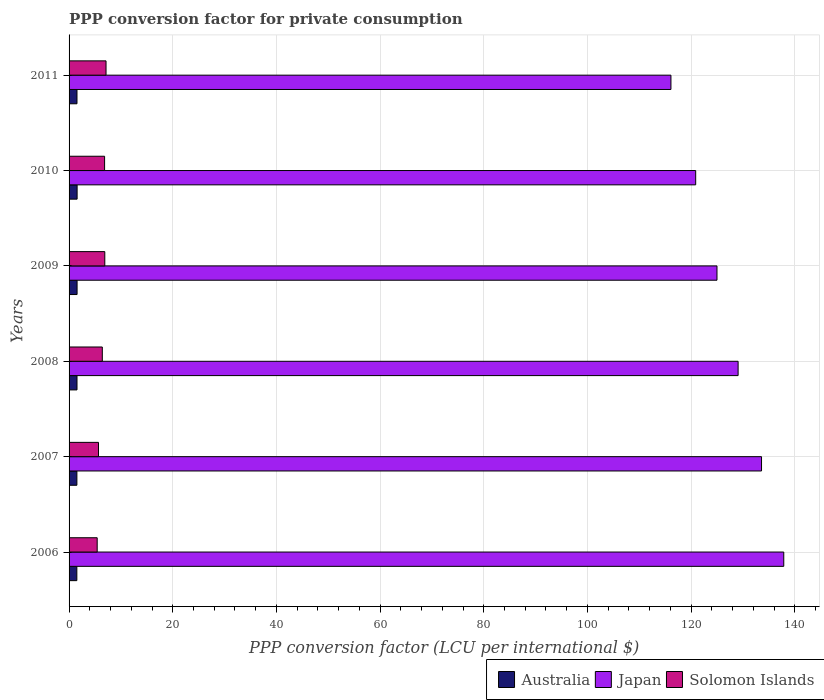How many different coloured bars are there?
Keep it short and to the point. 3. How many groups of bars are there?
Give a very brief answer. 6. How many bars are there on the 3rd tick from the top?
Your answer should be very brief. 3. How many bars are there on the 6th tick from the bottom?
Give a very brief answer. 3. What is the label of the 6th group of bars from the top?
Your answer should be compact. 2006. What is the PPP conversion factor for private consumption in Japan in 2007?
Offer a very short reply. 133.58. Across all years, what is the maximum PPP conversion factor for private consumption in Japan?
Your response must be concise. 137.87. Across all years, what is the minimum PPP conversion factor for private consumption in Solomon Islands?
Offer a very short reply. 5.42. In which year was the PPP conversion factor for private consumption in Australia maximum?
Your answer should be very brief. 2010. In which year was the PPP conversion factor for private consumption in Solomon Islands minimum?
Give a very brief answer. 2006. What is the total PPP conversion factor for private consumption in Japan in the graph?
Your answer should be very brief. 762.47. What is the difference between the PPP conversion factor for private consumption in Solomon Islands in 2007 and that in 2010?
Give a very brief answer. -1.18. What is the difference between the PPP conversion factor for private consumption in Australia in 2011 and the PPP conversion factor for private consumption in Japan in 2008?
Give a very brief answer. -127.53. What is the average PPP conversion factor for private consumption in Solomon Islands per year?
Offer a very short reply. 6.4. In the year 2008, what is the difference between the PPP conversion factor for private consumption in Japan and PPP conversion factor for private consumption in Solomon Islands?
Give a very brief answer. 122.65. What is the ratio of the PPP conversion factor for private consumption in Australia in 2007 to that in 2010?
Provide a succinct answer. 0.97. Is the difference between the PPP conversion factor for private consumption in Japan in 2006 and 2009 greater than the difference between the PPP conversion factor for private consumption in Solomon Islands in 2006 and 2009?
Ensure brevity in your answer.  Yes. What is the difference between the highest and the second highest PPP conversion factor for private consumption in Solomon Islands?
Your answer should be very brief. 0.24. What is the difference between the highest and the lowest PPP conversion factor for private consumption in Japan?
Keep it short and to the point. 21.76. Is the sum of the PPP conversion factor for private consumption in Solomon Islands in 2006 and 2009 greater than the maximum PPP conversion factor for private consumption in Japan across all years?
Provide a succinct answer. No. What does the 1st bar from the top in 2010 represents?
Ensure brevity in your answer.  Solomon Islands. Is it the case that in every year, the sum of the PPP conversion factor for private consumption in Solomon Islands and PPP conversion factor for private consumption in Japan is greater than the PPP conversion factor for private consumption in Australia?
Provide a succinct answer. Yes. How many bars are there?
Provide a succinct answer. 18. What is the difference between two consecutive major ticks on the X-axis?
Your answer should be compact. 20. Does the graph contain grids?
Your answer should be very brief. Yes. Where does the legend appear in the graph?
Offer a terse response. Bottom right. How many legend labels are there?
Offer a very short reply. 3. What is the title of the graph?
Provide a short and direct response. PPP conversion factor for private consumption. Does "Mexico" appear as one of the legend labels in the graph?
Provide a short and direct response. No. What is the label or title of the X-axis?
Offer a terse response. PPP conversion factor (LCU per international $). What is the label or title of the Y-axis?
Make the answer very short. Years. What is the PPP conversion factor (LCU per international $) of Australia in 2006?
Your answer should be very brief. 1.5. What is the PPP conversion factor (LCU per international $) in Japan in 2006?
Your answer should be compact. 137.87. What is the PPP conversion factor (LCU per international $) of Solomon Islands in 2006?
Provide a succinct answer. 5.42. What is the PPP conversion factor (LCU per international $) in Australia in 2007?
Keep it short and to the point. 1.51. What is the PPP conversion factor (LCU per international $) in Japan in 2007?
Offer a very short reply. 133.58. What is the PPP conversion factor (LCU per international $) in Solomon Islands in 2007?
Your response must be concise. 5.68. What is the PPP conversion factor (LCU per international $) of Australia in 2008?
Provide a short and direct response. 1.53. What is the PPP conversion factor (LCU per international $) in Japan in 2008?
Offer a terse response. 129.06. What is the PPP conversion factor (LCU per international $) in Solomon Islands in 2008?
Keep it short and to the point. 6.41. What is the PPP conversion factor (LCU per international $) in Australia in 2009?
Make the answer very short. 1.54. What is the PPP conversion factor (LCU per international $) in Japan in 2009?
Your response must be concise. 124.99. What is the PPP conversion factor (LCU per international $) in Solomon Islands in 2009?
Your answer should be compact. 6.89. What is the PPP conversion factor (LCU per international $) of Australia in 2010?
Offer a very short reply. 1.55. What is the PPP conversion factor (LCU per international $) of Japan in 2010?
Keep it short and to the point. 120.88. What is the PPP conversion factor (LCU per international $) in Solomon Islands in 2010?
Keep it short and to the point. 6.85. What is the PPP conversion factor (LCU per international $) in Australia in 2011?
Ensure brevity in your answer.  1.53. What is the PPP conversion factor (LCU per international $) of Japan in 2011?
Your answer should be compact. 116.1. What is the PPP conversion factor (LCU per international $) in Solomon Islands in 2011?
Your answer should be very brief. 7.13. Across all years, what is the maximum PPP conversion factor (LCU per international $) of Australia?
Your answer should be very brief. 1.55. Across all years, what is the maximum PPP conversion factor (LCU per international $) in Japan?
Your answer should be compact. 137.87. Across all years, what is the maximum PPP conversion factor (LCU per international $) of Solomon Islands?
Provide a short and direct response. 7.13. Across all years, what is the minimum PPP conversion factor (LCU per international $) of Australia?
Provide a succinct answer. 1.5. Across all years, what is the minimum PPP conversion factor (LCU per international $) in Japan?
Your answer should be compact. 116.1. Across all years, what is the minimum PPP conversion factor (LCU per international $) in Solomon Islands?
Offer a very short reply. 5.42. What is the total PPP conversion factor (LCU per international $) in Australia in the graph?
Offer a very short reply. 9.16. What is the total PPP conversion factor (LCU per international $) in Japan in the graph?
Ensure brevity in your answer.  762.47. What is the total PPP conversion factor (LCU per international $) of Solomon Islands in the graph?
Give a very brief answer. 38.39. What is the difference between the PPP conversion factor (LCU per international $) in Australia in 2006 and that in 2007?
Your answer should be very brief. -0.01. What is the difference between the PPP conversion factor (LCU per international $) of Japan in 2006 and that in 2007?
Your response must be concise. 4.29. What is the difference between the PPP conversion factor (LCU per international $) of Solomon Islands in 2006 and that in 2007?
Your response must be concise. -0.25. What is the difference between the PPP conversion factor (LCU per international $) in Australia in 2006 and that in 2008?
Give a very brief answer. -0.03. What is the difference between the PPP conversion factor (LCU per international $) in Japan in 2006 and that in 2008?
Keep it short and to the point. 8.81. What is the difference between the PPP conversion factor (LCU per international $) in Solomon Islands in 2006 and that in 2008?
Provide a succinct answer. -0.99. What is the difference between the PPP conversion factor (LCU per international $) in Australia in 2006 and that in 2009?
Offer a very short reply. -0.05. What is the difference between the PPP conversion factor (LCU per international $) of Japan in 2006 and that in 2009?
Offer a terse response. 12.88. What is the difference between the PPP conversion factor (LCU per international $) of Solomon Islands in 2006 and that in 2009?
Make the answer very short. -1.47. What is the difference between the PPP conversion factor (LCU per international $) of Australia in 2006 and that in 2010?
Keep it short and to the point. -0.05. What is the difference between the PPP conversion factor (LCU per international $) in Japan in 2006 and that in 2010?
Make the answer very short. 16.99. What is the difference between the PPP conversion factor (LCU per international $) of Solomon Islands in 2006 and that in 2010?
Keep it short and to the point. -1.43. What is the difference between the PPP conversion factor (LCU per international $) in Australia in 2006 and that in 2011?
Ensure brevity in your answer.  -0.03. What is the difference between the PPP conversion factor (LCU per international $) in Japan in 2006 and that in 2011?
Your answer should be very brief. 21.76. What is the difference between the PPP conversion factor (LCU per international $) in Solomon Islands in 2006 and that in 2011?
Keep it short and to the point. -1.71. What is the difference between the PPP conversion factor (LCU per international $) of Australia in 2007 and that in 2008?
Provide a short and direct response. -0.02. What is the difference between the PPP conversion factor (LCU per international $) in Japan in 2007 and that in 2008?
Give a very brief answer. 4.52. What is the difference between the PPP conversion factor (LCU per international $) of Solomon Islands in 2007 and that in 2008?
Your answer should be compact. -0.74. What is the difference between the PPP conversion factor (LCU per international $) in Australia in 2007 and that in 2009?
Give a very brief answer. -0.04. What is the difference between the PPP conversion factor (LCU per international $) of Japan in 2007 and that in 2009?
Provide a succinct answer. 8.59. What is the difference between the PPP conversion factor (LCU per international $) of Solomon Islands in 2007 and that in 2009?
Your answer should be compact. -1.22. What is the difference between the PPP conversion factor (LCU per international $) of Australia in 2007 and that in 2010?
Your answer should be very brief. -0.04. What is the difference between the PPP conversion factor (LCU per international $) of Japan in 2007 and that in 2010?
Ensure brevity in your answer.  12.7. What is the difference between the PPP conversion factor (LCU per international $) in Solomon Islands in 2007 and that in 2010?
Keep it short and to the point. -1.18. What is the difference between the PPP conversion factor (LCU per international $) in Australia in 2007 and that in 2011?
Your answer should be very brief. -0.02. What is the difference between the PPP conversion factor (LCU per international $) of Japan in 2007 and that in 2011?
Keep it short and to the point. 17.48. What is the difference between the PPP conversion factor (LCU per international $) in Solomon Islands in 2007 and that in 2011?
Your answer should be compact. -1.45. What is the difference between the PPP conversion factor (LCU per international $) in Australia in 2008 and that in 2009?
Make the answer very short. -0.01. What is the difference between the PPP conversion factor (LCU per international $) in Japan in 2008 and that in 2009?
Your answer should be compact. 4.07. What is the difference between the PPP conversion factor (LCU per international $) in Solomon Islands in 2008 and that in 2009?
Provide a succinct answer. -0.48. What is the difference between the PPP conversion factor (LCU per international $) of Australia in 2008 and that in 2010?
Ensure brevity in your answer.  -0.02. What is the difference between the PPP conversion factor (LCU per international $) in Japan in 2008 and that in 2010?
Your answer should be compact. 8.18. What is the difference between the PPP conversion factor (LCU per international $) in Solomon Islands in 2008 and that in 2010?
Your answer should be very brief. -0.44. What is the difference between the PPP conversion factor (LCU per international $) of Australia in 2008 and that in 2011?
Your answer should be very brief. 0. What is the difference between the PPP conversion factor (LCU per international $) of Japan in 2008 and that in 2011?
Provide a short and direct response. 12.96. What is the difference between the PPP conversion factor (LCU per international $) in Solomon Islands in 2008 and that in 2011?
Provide a short and direct response. -0.72. What is the difference between the PPP conversion factor (LCU per international $) of Australia in 2009 and that in 2010?
Your response must be concise. -0.01. What is the difference between the PPP conversion factor (LCU per international $) of Japan in 2009 and that in 2010?
Give a very brief answer. 4.11. What is the difference between the PPP conversion factor (LCU per international $) in Solomon Islands in 2009 and that in 2010?
Make the answer very short. 0.04. What is the difference between the PPP conversion factor (LCU per international $) in Australia in 2009 and that in 2011?
Ensure brevity in your answer.  0.02. What is the difference between the PPP conversion factor (LCU per international $) of Japan in 2009 and that in 2011?
Your answer should be very brief. 8.88. What is the difference between the PPP conversion factor (LCU per international $) in Solomon Islands in 2009 and that in 2011?
Your answer should be compact. -0.24. What is the difference between the PPP conversion factor (LCU per international $) of Australia in 2010 and that in 2011?
Offer a terse response. 0.03. What is the difference between the PPP conversion factor (LCU per international $) of Japan in 2010 and that in 2011?
Ensure brevity in your answer.  4.78. What is the difference between the PPP conversion factor (LCU per international $) of Solomon Islands in 2010 and that in 2011?
Keep it short and to the point. -0.28. What is the difference between the PPP conversion factor (LCU per international $) in Australia in 2006 and the PPP conversion factor (LCU per international $) in Japan in 2007?
Provide a short and direct response. -132.08. What is the difference between the PPP conversion factor (LCU per international $) of Australia in 2006 and the PPP conversion factor (LCU per international $) of Solomon Islands in 2007?
Make the answer very short. -4.18. What is the difference between the PPP conversion factor (LCU per international $) in Japan in 2006 and the PPP conversion factor (LCU per international $) in Solomon Islands in 2007?
Keep it short and to the point. 132.19. What is the difference between the PPP conversion factor (LCU per international $) of Australia in 2006 and the PPP conversion factor (LCU per international $) of Japan in 2008?
Provide a succinct answer. -127.56. What is the difference between the PPP conversion factor (LCU per international $) of Australia in 2006 and the PPP conversion factor (LCU per international $) of Solomon Islands in 2008?
Your response must be concise. -4.92. What is the difference between the PPP conversion factor (LCU per international $) of Japan in 2006 and the PPP conversion factor (LCU per international $) of Solomon Islands in 2008?
Your response must be concise. 131.45. What is the difference between the PPP conversion factor (LCU per international $) of Australia in 2006 and the PPP conversion factor (LCU per international $) of Japan in 2009?
Your response must be concise. -123.49. What is the difference between the PPP conversion factor (LCU per international $) of Australia in 2006 and the PPP conversion factor (LCU per international $) of Solomon Islands in 2009?
Offer a very short reply. -5.39. What is the difference between the PPP conversion factor (LCU per international $) of Japan in 2006 and the PPP conversion factor (LCU per international $) of Solomon Islands in 2009?
Offer a terse response. 130.97. What is the difference between the PPP conversion factor (LCU per international $) of Australia in 2006 and the PPP conversion factor (LCU per international $) of Japan in 2010?
Your answer should be very brief. -119.38. What is the difference between the PPP conversion factor (LCU per international $) of Australia in 2006 and the PPP conversion factor (LCU per international $) of Solomon Islands in 2010?
Your answer should be compact. -5.36. What is the difference between the PPP conversion factor (LCU per international $) of Japan in 2006 and the PPP conversion factor (LCU per international $) of Solomon Islands in 2010?
Your answer should be compact. 131.01. What is the difference between the PPP conversion factor (LCU per international $) in Australia in 2006 and the PPP conversion factor (LCU per international $) in Japan in 2011?
Your answer should be compact. -114.61. What is the difference between the PPP conversion factor (LCU per international $) in Australia in 2006 and the PPP conversion factor (LCU per international $) in Solomon Islands in 2011?
Keep it short and to the point. -5.63. What is the difference between the PPP conversion factor (LCU per international $) of Japan in 2006 and the PPP conversion factor (LCU per international $) of Solomon Islands in 2011?
Provide a short and direct response. 130.74. What is the difference between the PPP conversion factor (LCU per international $) of Australia in 2007 and the PPP conversion factor (LCU per international $) of Japan in 2008?
Your answer should be very brief. -127.55. What is the difference between the PPP conversion factor (LCU per international $) of Australia in 2007 and the PPP conversion factor (LCU per international $) of Solomon Islands in 2008?
Provide a succinct answer. -4.91. What is the difference between the PPP conversion factor (LCU per international $) of Japan in 2007 and the PPP conversion factor (LCU per international $) of Solomon Islands in 2008?
Offer a very short reply. 127.17. What is the difference between the PPP conversion factor (LCU per international $) in Australia in 2007 and the PPP conversion factor (LCU per international $) in Japan in 2009?
Offer a terse response. -123.48. What is the difference between the PPP conversion factor (LCU per international $) in Australia in 2007 and the PPP conversion factor (LCU per international $) in Solomon Islands in 2009?
Provide a succinct answer. -5.39. What is the difference between the PPP conversion factor (LCU per international $) in Japan in 2007 and the PPP conversion factor (LCU per international $) in Solomon Islands in 2009?
Make the answer very short. 126.69. What is the difference between the PPP conversion factor (LCU per international $) in Australia in 2007 and the PPP conversion factor (LCU per international $) in Japan in 2010?
Make the answer very short. -119.37. What is the difference between the PPP conversion factor (LCU per international $) in Australia in 2007 and the PPP conversion factor (LCU per international $) in Solomon Islands in 2010?
Offer a terse response. -5.35. What is the difference between the PPP conversion factor (LCU per international $) in Japan in 2007 and the PPP conversion factor (LCU per international $) in Solomon Islands in 2010?
Provide a short and direct response. 126.73. What is the difference between the PPP conversion factor (LCU per international $) in Australia in 2007 and the PPP conversion factor (LCU per international $) in Japan in 2011?
Provide a short and direct response. -114.6. What is the difference between the PPP conversion factor (LCU per international $) in Australia in 2007 and the PPP conversion factor (LCU per international $) in Solomon Islands in 2011?
Provide a succinct answer. -5.62. What is the difference between the PPP conversion factor (LCU per international $) in Japan in 2007 and the PPP conversion factor (LCU per international $) in Solomon Islands in 2011?
Keep it short and to the point. 126.45. What is the difference between the PPP conversion factor (LCU per international $) in Australia in 2008 and the PPP conversion factor (LCU per international $) in Japan in 2009?
Your response must be concise. -123.46. What is the difference between the PPP conversion factor (LCU per international $) of Australia in 2008 and the PPP conversion factor (LCU per international $) of Solomon Islands in 2009?
Provide a succinct answer. -5.36. What is the difference between the PPP conversion factor (LCU per international $) in Japan in 2008 and the PPP conversion factor (LCU per international $) in Solomon Islands in 2009?
Provide a succinct answer. 122.17. What is the difference between the PPP conversion factor (LCU per international $) in Australia in 2008 and the PPP conversion factor (LCU per international $) in Japan in 2010?
Make the answer very short. -119.35. What is the difference between the PPP conversion factor (LCU per international $) in Australia in 2008 and the PPP conversion factor (LCU per international $) in Solomon Islands in 2010?
Make the answer very short. -5.32. What is the difference between the PPP conversion factor (LCU per international $) in Japan in 2008 and the PPP conversion factor (LCU per international $) in Solomon Islands in 2010?
Ensure brevity in your answer.  122.21. What is the difference between the PPP conversion factor (LCU per international $) in Australia in 2008 and the PPP conversion factor (LCU per international $) in Japan in 2011?
Your response must be concise. -114.57. What is the difference between the PPP conversion factor (LCU per international $) of Australia in 2008 and the PPP conversion factor (LCU per international $) of Solomon Islands in 2011?
Ensure brevity in your answer.  -5.6. What is the difference between the PPP conversion factor (LCU per international $) of Japan in 2008 and the PPP conversion factor (LCU per international $) of Solomon Islands in 2011?
Provide a short and direct response. 121.93. What is the difference between the PPP conversion factor (LCU per international $) in Australia in 2009 and the PPP conversion factor (LCU per international $) in Japan in 2010?
Your answer should be very brief. -119.33. What is the difference between the PPP conversion factor (LCU per international $) of Australia in 2009 and the PPP conversion factor (LCU per international $) of Solomon Islands in 2010?
Provide a short and direct response. -5.31. What is the difference between the PPP conversion factor (LCU per international $) of Japan in 2009 and the PPP conversion factor (LCU per international $) of Solomon Islands in 2010?
Your answer should be very brief. 118.13. What is the difference between the PPP conversion factor (LCU per international $) of Australia in 2009 and the PPP conversion factor (LCU per international $) of Japan in 2011?
Provide a succinct answer. -114.56. What is the difference between the PPP conversion factor (LCU per international $) in Australia in 2009 and the PPP conversion factor (LCU per international $) in Solomon Islands in 2011?
Make the answer very short. -5.59. What is the difference between the PPP conversion factor (LCU per international $) of Japan in 2009 and the PPP conversion factor (LCU per international $) of Solomon Islands in 2011?
Give a very brief answer. 117.85. What is the difference between the PPP conversion factor (LCU per international $) of Australia in 2010 and the PPP conversion factor (LCU per international $) of Japan in 2011?
Your answer should be compact. -114.55. What is the difference between the PPP conversion factor (LCU per international $) in Australia in 2010 and the PPP conversion factor (LCU per international $) in Solomon Islands in 2011?
Keep it short and to the point. -5.58. What is the difference between the PPP conversion factor (LCU per international $) in Japan in 2010 and the PPP conversion factor (LCU per international $) in Solomon Islands in 2011?
Give a very brief answer. 113.75. What is the average PPP conversion factor (LCU per international $) in Australia per year?
Ensure brevity in your answer.  1.53. What is the average PPP conversion factor (LCU per international $) in Japan per year?
Offer a terse response. 127.08. What is the average PPP conversion factor (LCU per international $) of Solomon Islands per year?
Your answer should be compact. 6.4. In the year 2006, what is the difference between the PPP conversion factor (LCU per international $) of Australia and PPP conversion factor (LCU per international $) of Japan?
Your answer should be compact. -136.37. In the year 2006, what is the difference between the PPP conversion factor (LCU per international $) of Australia and PPP conversion factor (LCU per international $) of Solomon Islands?
Your answer should be very brief. -3.92. In the year 2006, what is the difference between the PPP conversion factor (LCU per international $) of Japan and PPP conversion factor (LCU per international $) of Solomon Islands?
Make the answer very short. 132.44. In the year 2007, what is the difference between the PPP conversion factor (LCU per international $) of Australia and PPP conversion factor (LCU per international $) of Japan?
Your answer should be compact. -132.07. In the year 2007, what is the difference between the PPP conversion factor (LCU per international $) in Australia and PPP conversion factor (LCU per international $) in Solomon Islands?
Offer a terse response. -4.17. In the year 2007, what is the difference between the PPP conversion factor (LCU per international $) of Japan and PPP conversion factor (LCU per international $) of Solomon Islands?
Make the answer very short. 127.9. In the year 2008, what is the difference between the PPP conversion factor (LCU per international $) in Australia and PPP conversion factor (LCU per international $) in Japan?
Keep it short and to the point. -127.53. In the year 2008, what is the difference between the PPP conversion factor (LCU per international $) in Australia and PPP conversion factor (LCU per international $) in Solomon Islands?
Provide a short and direct response. -4.88. In the year 2008, what is the difference between the PPP conversion factor (LCU per international $) in Japan and PPP conversion factor (LCU per international $) in Solomon Islands?
Give a very brief answer. 122.65. In the year 2009, what is the difference between the PPP conversion factor (LCU per international $) of Australia and PPP conversion factor (LCU per international $) of Japan?
Offer a very short reply. -123.44. In the year 2009, what is the difference between the PPP conversion factor (LCU per international $) in Australia and PPP conversion factor (LCU per international $) in Solomon Islands?
Offer a terse response. -5.35. In the year 2009, what is the difference between the PPP conversion factor (LCU per international $) of Japan and PPP conversion factor (LCU per international $) of Solomon Islands?
Keep it short and to the point. 118.09. In the year 2010, what is the difference between the PPP conversion factor (LCU per international $) of Australia and PPP conversion factor (LCU per international $) of Japan?
Your response must be concise. -119.33. In the year 2010, what is the difference between the PPP conversion factor (LCU per international $) in Australia and PPP conversion factor (LCU per international $) in Solomon Islands?
Your response must be concise. -5.3. In the year 2010, what is the difference between the PPP conversion factor (LCU per international $) of Japan and PPP conversion factor (LCU per international $) of Solomon Islands?
Provide a succinct answer. 114.03. In the year 2011, what is the difference between the PPP conversion factor (LCU per international $) of Australia and PPP conversion factor (LCU per international $) of Japan?
Your answer should be compact. -114.58. In the year 2011, what is the difference between the PPP conversion factor (LCU per international $) of Australia and PPP conversion factor (LCU per international $) of Solomon Islands?
Your answer should be compact. -5.6. In the year 2011, what is the difference between the PPP conversion factor (LCU per international $) in Japan and PPP conversion factor (LCU per international $) in Solomon Islands?
Offer a terse response. 108.97. What is the ratio of the PPP conversion factor (LCU per international $) in Australia in 2006 to that in 2007?
Offer a terse response. 0.99. What is the ratio of the PPP conversion factor (LCU per international $) in Japan in 2006 to that in 2007?
Offer a very short reply. 1.03. What is the ratio of the PPP conversion factor (LCU per international $) of Solomon Islands in 2006 to that in 2007?
Keep it short and to the point. 0.96. What is the ratio of the PPP conversion factor (LCU per international $) in Australia in 2006 to that in 2008?
Your answer should be compact. 0.98. What is the ratio of the PPP conversion factor (LCU per international $) of Japan in 2006 to that in 2008?
Offer a very short reply. 1.07. What is the ratio of the PPP conversion factor (LCU per international $) of Solomon Islands in 2006 to that in 2008?
Your answer should be compact. 0.85. What is the ratio of the PPP conversion factor (LCU per international $) in Australia in 2006 to that in 2009?
Give a very brief answer. 0.97. What is the ratio of the PPP conversion factor (LCU per international $) of Japan in 2006 to that in 2009?
Provide a short and direct response. 1.1. What is the ratio of the PPP conversion factor (LCU per international $) in Solomon Islands in 2006 to that in 2009?
Provide a succinct answer. 0.79. What is the ratio of the PPP conversion factor (LCU per international $) in Australia in 2006 to that in 2010?
Make the answer very short. 0.97. What is the ratio of the PPP conversion factor (LCU per international $) of Japan in 2006 to that in 2010?
Your answer should be compact. 1.14. What is the ratio of the PPP conversion factor (LCU per international $) in Solomon Islands in 2006 to that in 2010?
Give a very brief answer. 0.79. What is the ratio of the PPP conversion factor (LCU per international $) of Australia in 2006 to that in 2011?
Make the answer very short. 0.98. What is the ratio of the PPP conversion factor (LCU per international $) of Japan in 2006 to that in 2011?
Ensure brevity in your answer.  1.19. What is the ratio of the PPP conversion factor (LCU per international $) in Solomon Islands in 2006 to that in 2011?
Your response must be concise. 0.76. What is the ratio of the PPP conversion factor (LCU per international $) in Australia in 2007 to that in 2008?
Provide a succinct answer. 0.98. What is the ratio of the PPP conversion factor (LCU per international $) in Japan in 2007 to that in 2008?
Provide a succinct answer. 1.03. What is the ratio of the PPP conversion factor (LCU per international $) of Solomon Islands in 2007 to that in 2008?
Keep it short and to the point. 0.89. What is the ratio of the PPP conversion factor (LCU per international $) in Australia in 2007 to that in 2009?
Offer a very short reply. 0.98. What is the ratio of the PPP conversion factor (LCU per international $) in Japan in 2007 to that in 2009?
Keep it short and to the point. 1.07. What is the ratio of the PPP conversion factor (LCU per international $) of Solomon Islands in 2007 to that in 2009?
Offer a very short reply. 0.82. What is the ratio of the PPP conversion factor (LCU per international $) in Australia in 2007 to that in 2010?
Keep it short and to the point. 0.97. What is the ratio of the PPP conversion factor (LCU per international $) in Japan in 2007 to that in 2010?
Your answer should be very brief. 1.11. What is the ratio of the PPP conversion factor (LCU per international $) in Solomon Islands in 2007 to that in 2010?
Your answer should be very brief. 0.83. What is the ratio of the PPP conversion factor (LCU per international $) of Australia in 2007 to that in 2011?
Provide a short and direct response. 0.99. What is the ratio of the PPP conversion factor (LCU per international $) of Japan in 2007 to that in 2011?
Offer a terse response. 1.15. What is the ratio of the PPP conversion factor (LCU per international $) of Solomon Islands in 2007 to that in 2011?
Your answer should be compact. 0.8. What is the ratio of the PPP conversion factor (LCU per international $) of Australia in 2008 to that in 2009?
Ensure brevity in your answer.  0.99. What is the ratio of the PPP conversion factor (LCU per international $) in Japan in 2008 to that in 2009?
Your answer should be very brief. 1.03. What is the ratio of the PPP conversion factor (LCU per international $) of Solomon Islands in 2008 to that in 2009?
Make the answer very short. 0.93. What is the ratio of the PPP conversion factor (LCU per international $) of Australia in 2008 to that in 2010?
Your answer should be very brief. 0.99. What is the ratio of the PPP conversion factor (LCU per international $) in Japan in 2008 to that in 2010?
Provide a short and direct response. 1.07. What is the ratio of the PPP conversion factor (LCU per international $) in Solomon Islands in 2008 to that in 2010?
Make the answer very short. 0.94. What is the ratio of the PPP conversion factor (LCU per international $) in Japan in 2008 to that in 2011?
Offer a terse response. 1.11. What is the ratio of the PPP conversion factor (LCU per international $) in Solomon Islands in 2008 to that in 2011?
Provide a short and direct response. 0.9. What is the ratio of the PPP conversion factor (LCU per international $) of Australia in 2009 to that in 2010?
Provide a short and direct response. 0.99. What is the ratio of the PPP conversion factor (LCU per international $) in Japan in 2009 to that in 2010?
Keep it short and to the point. 1.03. What is the ratio of the PPP conversion factor (LCU per international $) in Solomon Islands in 2009 to that in 2010?
Your answer should be very brief. 1.01. What is the ratio of the PPP conversion factor (LCU per international $) of Australia in 2009 to that in 2011?
Keep it short and to the point. 1.01. What is the ratio of the PPP conversion factor (LCU per international $) of Japan in 2009 to that in 2011?
Your answer should be compact. 1.08. What is the ratio of the PPP conversion factor (LCU per international $) of Solomon Islands in 2009 to that in 2011?
Offer a very short reply. 0.97. What is the ratio of the PPP conversion factor (LCU per international $) of Australia in 2010 to that in 2011?
Make the answer very short. 1.02. What is the ratio of the PPP conversion factor (LCU per international $) in Japan in 2010 to that in 2011?
Offer a terse response. 1.04. What is the ratio of the PPP conversion factor (LCU per international $) of Solomon Islands in 2010 to that in 2011?
Keep it short and to the point. 0.96. What is the difference between the highest and the second highest PPP conversion factor (LCU per international $) of Australia?
Offer a very short reply. 0.01. What is the difference between the highest and the second highest PPP conversion factor (LCU per international $) of Japan?
Your response must be concise. 4.29. What is the difference between the highest and the second highest PPP conversion factor (LCU per international $) of Solomon Islands?
Give a very brief answer. 0.24. What is the difference between the highest and the lowest PPP conversion factor (LCU per international $) in Australia?
Offer a terse response. 0.05. What is the difference between the highest and the lowest PPP conversion factor (LCU per international $) in Japan?
Ensure brevity in your answer.  21.76. What is the difference between the highest and the lowest PPP conversion factor (LCU per international $) in Solomon Islands?
Provide a succinct answer. 1.71. 